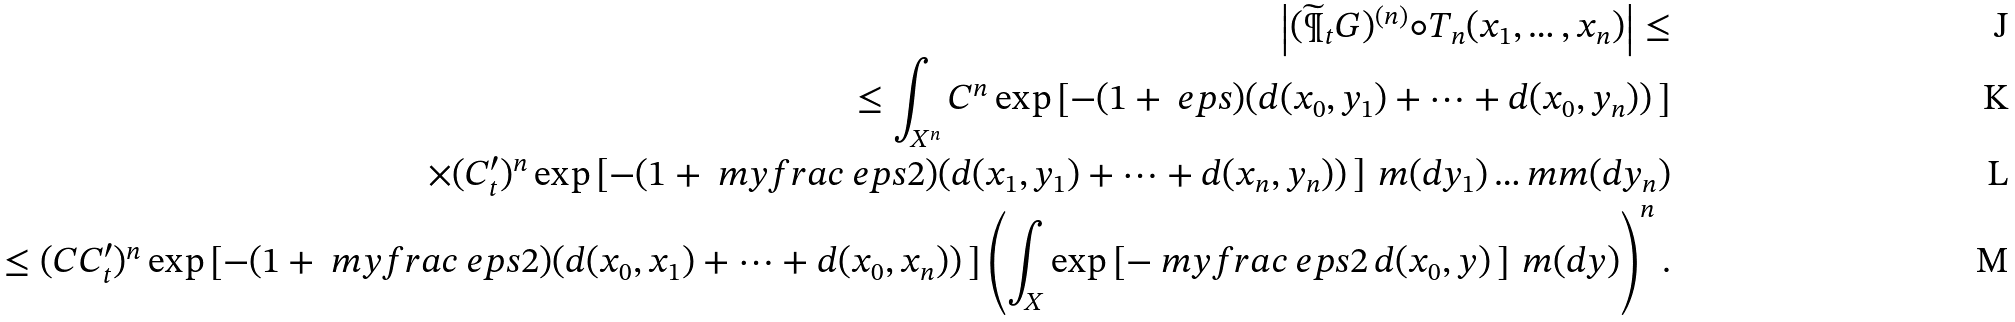Convert formula to latex. <formula><loc_0><loc_0><loc_500><loc_500>\left | ( \widetilde { \P } _ { t } G ) ^ { ( n ) } \circ T _ { n } ( x _ { 1 } , \dots , x _ { n } ) \right | \leq \\ \leq \int _ { X ^ { n } } C ^ { n } \exp \left [ - ( 1 + \ e p s ) ( d ( x _ { 0 } , y _ { 1 } ) + \dots + d ( x _ { 0 } , y _ { n } ) ) \, \right ] \\ \times ( C _ { t } ^ { \prime } ) ^ { n } \exp \left [ - ( 1 + \ m y f r a c \ e p s 2 ) ( d ( x _ { 1 } , y _ { 1 } ) + \dots + d ( x _ { n } , y _ { n } ) ) \, \right ] \, m ( d y _ { 1 } ) \dots m m ( d y _ { n } ) \\ \leq ( C C _ { t } ^ { \prime } ) ^ { n } \exp \left [ - ( 1 + \ m y f r a c \ e p s 2 ) ( d ( x _ { 0 } , x _ { 1 } ) + \dots + d ( x _ { 0 } , x _ { n } ) ) \, \right ] \left ( \int _ { X } \exp \left [ - \ m y f r a c \ e p s 2 \, d ( x _ { 0 } , y ) \, \right ] \, m ( d y ) \right ) ^ { n } .</formula> 